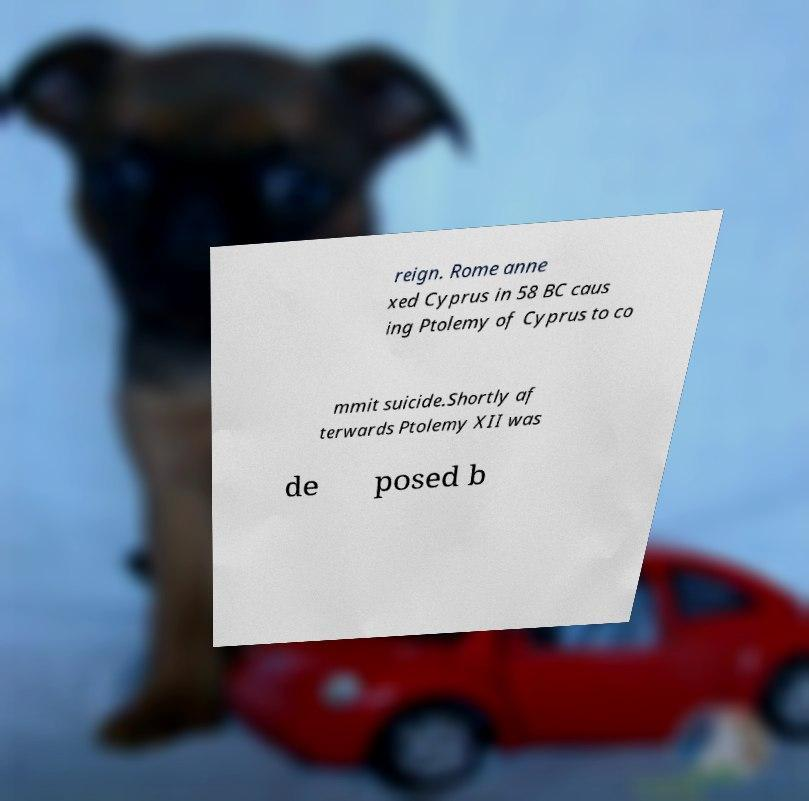There's text embedded in this image that I need extracted. Can you transcribe it verbatim? reign. Rome anne xed Cyprus in 58 BC caus ing Ptolemy of Cyprus to co mmit suicide.Shortly af terwards Ptolemy XII was de posed b 